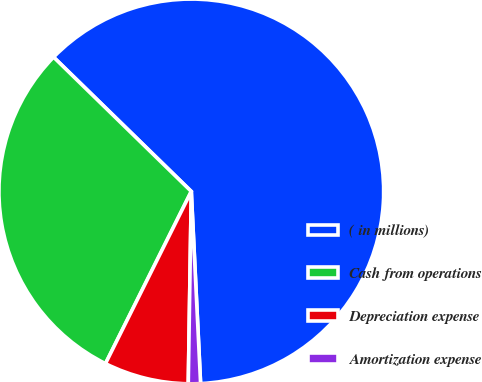Convert chart. <chart><loc_0><loc_0><loc_500><loc_500><pie_chart><fcel>( in millions)<fcel>Cash from operations<fcel>Depreciation expense<fcel>Amortization expense<nl><fcel>61.93%<fcel>29.94%<fcel>7.11%<fcel>1.02%<nl></chart> 